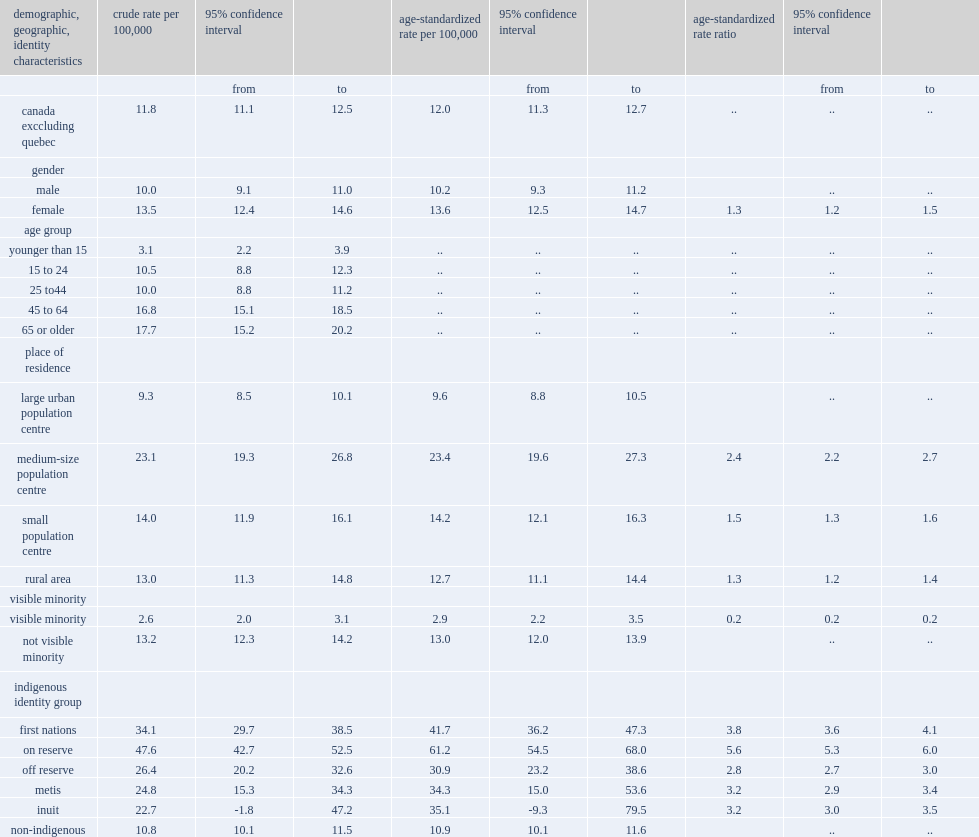What was the age-standardized rates of hop lower among visible minorities or among people who were not members of visible minority groups? Visible minority. 